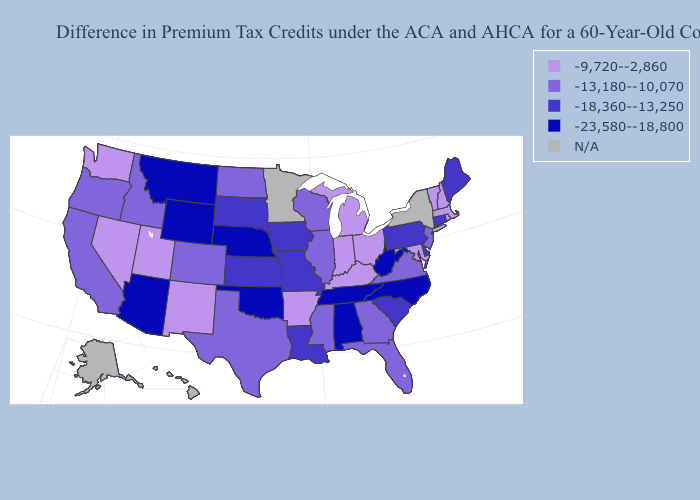What is the value of Vermont?
Concise answer only. -9,720--2,860. Name the states that have a value in the range -18,360--13,250?
Concise answer only. Connecticut, Delaware, Iowa, Kansas, Louisiana, Maine, Missouri, Pennsylvania, South Carolina, South Dakota. Which states have the lowest value in the USA?
Write a very short answer. Alabama, Arizona, Montana, Nebraska, North Carolina, Oklahoma, Tennessee, West Virginia, Wyoming. What is the lowest value in states that border Nevada?
Quick response, please. -23,580--18,800. What is the value of Arkansas?
Answer briefly. -9,720--2,860. What is the value of Maryland?
Be succinct. -9,720--2,860. Does the map have missing data?
Quick response, please. Yes. What is the highest value in states that border Michigan?
Answer briefly. -9,720--2,860. Which states have the lowest value in the West?
Keep it brief. Arizona, Montana, Wyoming. What is the value of Pennsylvania?
Keep it brief. -18,360--13,250. What is the value of Ohio?
Concise answer only. -9,720--2,860. Name the states that have a value in the range N/A?
Keep it brief. Alaska, Hawaii, Minnesota, New York. Among the states that border Iowa , which have the lowest value?
Quick response, please. Nebraska. 